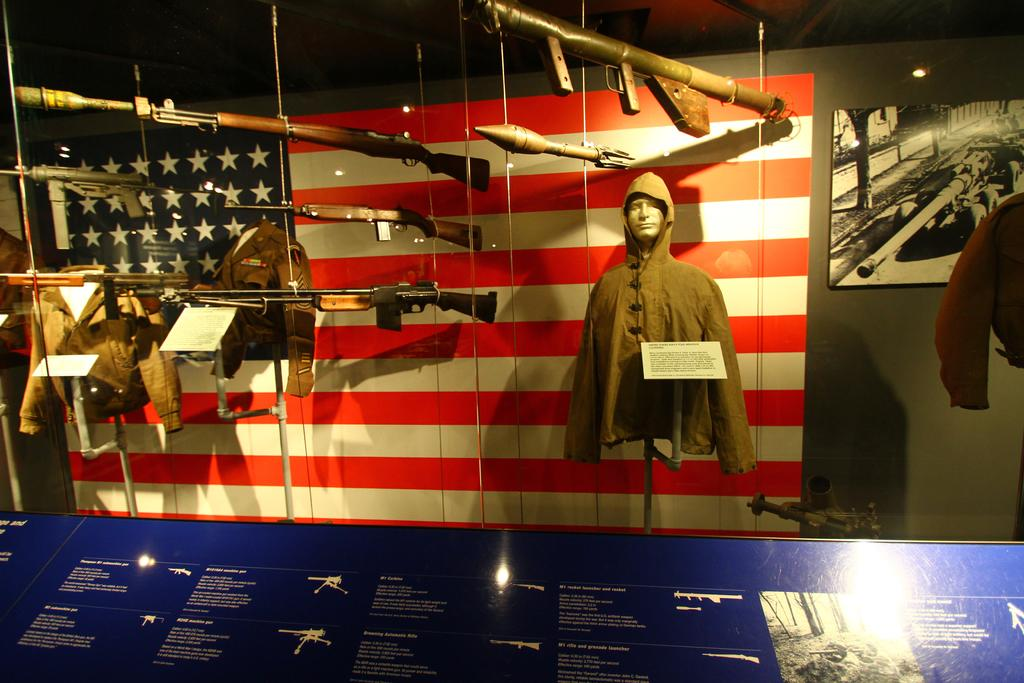What type of objects can be seen in the image? There are guns, jackets, boards, and a flag in the image. What is attached to the wall in the image? A frame is attached to the wall in the image. What color is one of the boards in the image? There is a blue color board in the image. Is there any text or writing on any of the boards? Something is written on the blue color board in the image. What type of pie is being served by the doctor in the image? There is no pie or doctor present in the image. Can you tell me how many scissors are visible in the image? There are no scissors visible in the image. 